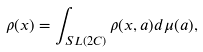<formula> <loc_0><loc_0><loc_500><loc_500>\rho ( x ) = \int _ { S L ( 2 C ) } \rho ( x , a ) d \mu ( a ) ,</formula> 